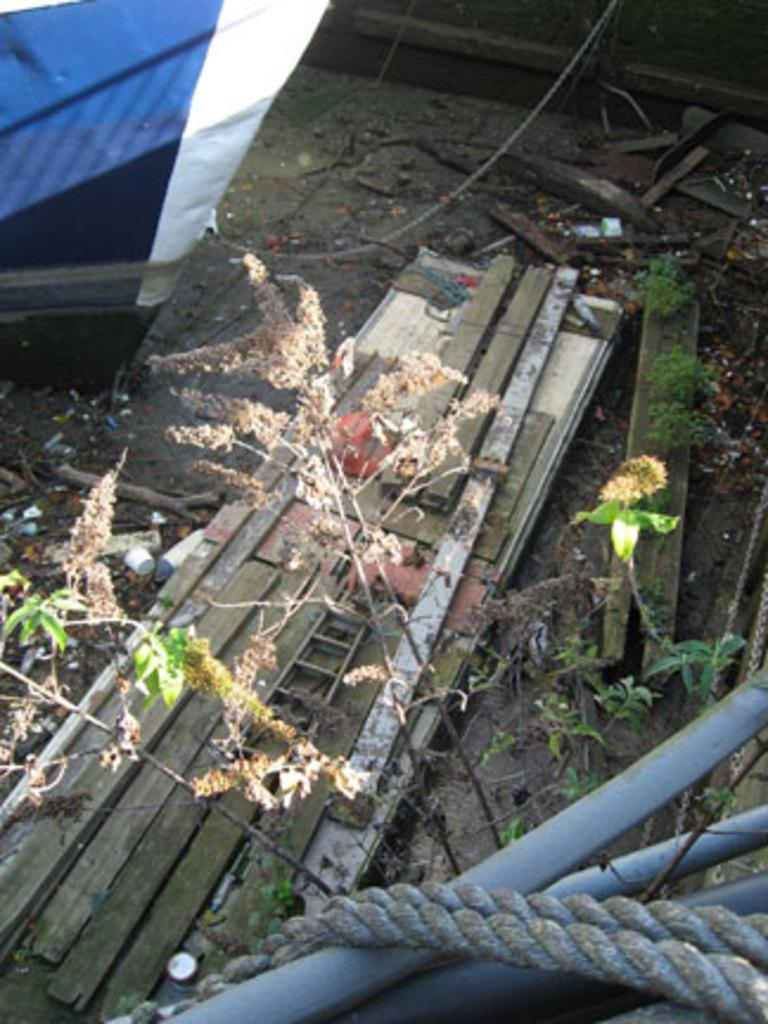What type of material is used for the planks in the image? The wooden planks in the image are made of wood. What other objects can be seen in the image besides the wooden planks? There are sticks, plants, ropes, metal rods, and many other objects on the ground in the image. Can you describe the boat in the image? There appears to be a boat in the top left corner of the image. What advice does the beginner dad give to the hen in the image? There is no beginner dad or hen present in the image. What type of food does the hen eat from the wooden planks in the image? There is no hen present in the image, so it is not possible to determine what type of food it might eat. 